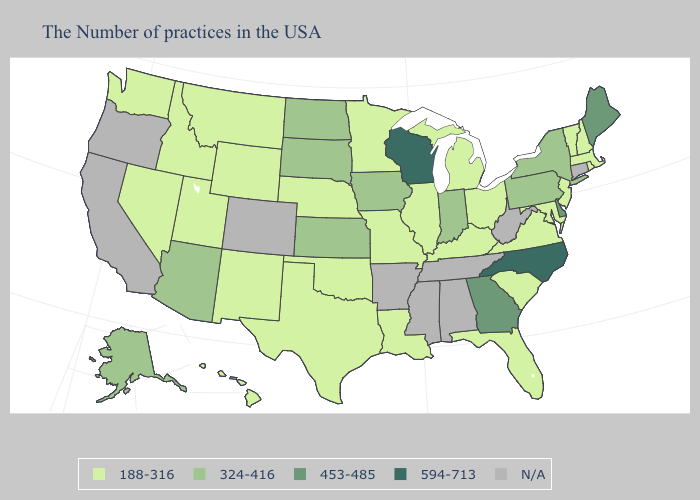Name the states that have a value in the range 594-713?
Be succinct. North Carolina, Wisconsin. Does the map have missing data?
Short answer required. Yes. Name the states that have a value in the range 453-485?
Concise answer only. Maine, Delaware, Georgia. What is the value of Utah?
Short answer required. 188-316. Among the states that border Indiana , which have the lowest value?
Concise answer only. Ohio, Michigan, Kentucky, Illinois. Which states have the highest value in the USA?
Answer briefly. North Carolina, Wisconsin. What is the lowest value in the MidWest?
Short answer required. 188-316. What is the lowest value in the MidWest?
Keep it brief. 188-316. Name the states that have a value in the range N/A?
Write a very short answer. Connecticut, West Virginia, Alabama, Tennessee, Mississippi, Arkansas, Colorado, California, Oregon. What is the highest value in the MidWest ?
Write a very short answer. 594-713. What is the value of Delaware?
Give a very brief answer. 453-485. Among the states that border Nebraska , does South Dakota have the highest value?
Write a very short answer. Yes. Name the states that have a value in the range 453-485?
Give a very brief answer. Maine, Delaware, Georgia. What is the value of Idaho?
Concise answer only. 188-316. 